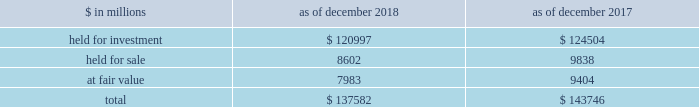The goldman sachs group , inc .
And subsidiaries notes to consolidated financial statements lending commitments the firm 2019s lending commitments are agreements to lend with fixed termination dates and depend on the satisfaction of all contractual conditions to borrowing .
These commitments are presented net of amounts syndicated to third parties .
The total commitment amount does not necessarily reflect actual future cash flows because the firm may syndicate all or substantial additional portions of these commitments .
In addition , commitments can expire unused or be reduced or cancelled at the counterparty 2019s request .
The table below presents information about lending commitments. .
In the table above : 2030 held for investment lending commitments are accounted for on an accrual basis .
See note 9 for further information about such commitments .
2030 held for sale lending commitments are accounted for at the lower of cost or fair value .
2030 gains or losses related to lending commitments at fair value , if any , are generally recorded , net of any fees in other principal transactions .
2030 substantially all lending commitments relates to the firm 2019s investing & lending segment .
Commercial lending .
The firm 2019s commercial lending commitments were primarily extended to investment-grade corporate borrowers .
Such commitments included $ 93.99 billion as of december 2018 and $ 85.98 billion as of december 2017 , related to relationship lending activities ( principally used for operating and general corporate purposes ) and $ 27.92 billion as of december 2018 and $ 42.41 billion as of december 2017 , related to other investment banking activities ( generally extended for contingent acquisition financing and are often intended to be short-term in nature , as borrowers often seek to replace them with other funding sources ) .
The firm also extends lending commitments in connection with other types of corporate lending , as well as commercial real estate financing .
See note 9 for further information about funded loans .
Sumitomo mitsui financial group , inc .
( smfg ) provides the firm with credit loss protection on certain approved loan commitments ( primarily investment-grade commercial lending commitments ) .
The notional amount of such loan commitments was $ 15.52 billion as of december 2018 and $ 25.70 billion as of december 2017 .
The credit loss protection on loan commitments provided by smfg is generally limited to 95% ( 95 % ) of the first loss the firm realizes on such commitments , up to a maximum of approximately $ 950 million .
In addition , subject to the satisfaction of certain conditions , upon the firm 2019s request , smfg will provide protection for 70% ( 70 % ) of additional losses on such commitments , up to a maximum of $ 1.0 billion , of which $ 550 million of protection had been provided as of both december 2018 and december 2017 .
The firm also uses other financial instruments to mitigate credit risks related to certain commitments not covered by smfg .
These instruments primarily include credit default swaps that reference the same or similar underlying instrument or entity , or credit default swaps that reference a market index .
Warehouse financing .
The firm provides financing to clients who warehouse financial assets .
These arrangements are secured by the warehoused assets , primarily consisting of consumer and corporate loans .
Contingent and forward starting collateralized agreements / forward starting collateralized financings forward starting collateralized agreements includes resale and securities borrowing agreements , and forward starting collateralized financings includes repurchase and secured lending agreements that settle at a future date , generally within three business days .
The firm also enters into commitments to provide contingent financing to its clients and counterparties through resale agreements .
The firm 2019s funding of these commitments depends on the satisfaction of all contractual conditions to the resale agreement and these commitments can expire unused .
Letters of credit the firm has commitments under letters of credit issued by various banks which the firm provides to counterparties in lieu of securities or cash to satisfy various collateral and margin deposit requirements .
Investment commitments investment commitments includes commitments to invest in private equity , real estate and other assets directly and through funds that the firm raises and manages .
Investment commitments included $ 2.42 billion as of december 2018 and $ 2.09 billion as of december 2017 , related to commitments to invest in funds managed by the firm .
If these commitments are called , they would be funded at market value on the date of investment .
Goldman sachs 2018 form 10-k 159 .
In millions for 2018 and 2017 , what was the lowest balance in held for investment? 
Computations: table_min(held for investment, none)
Answer: 120997.0. 